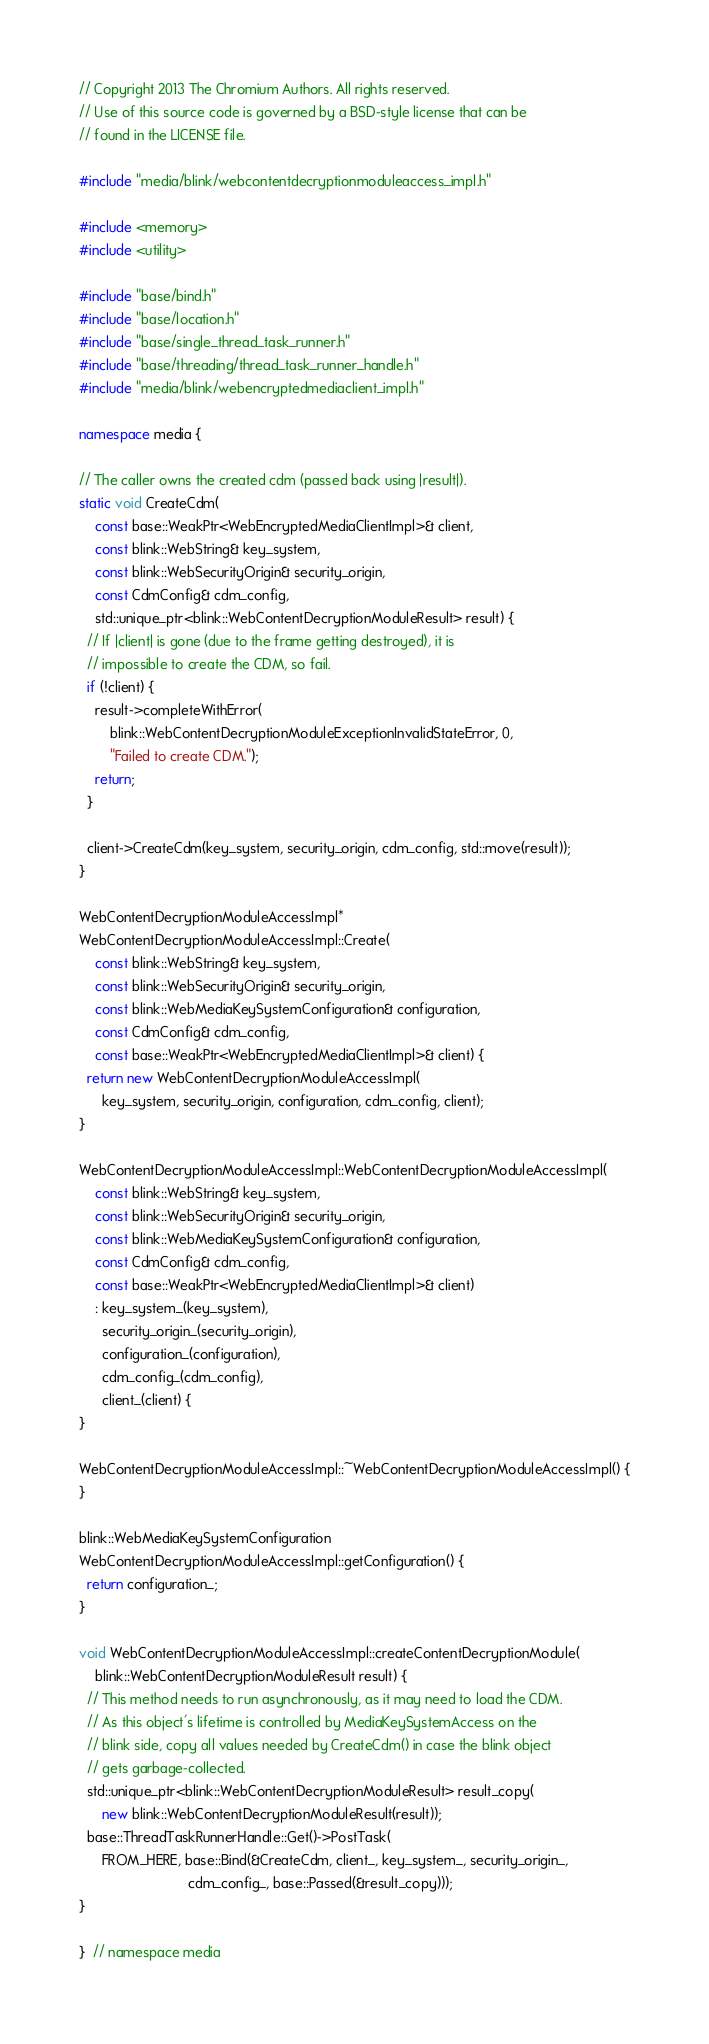Convert code to text. <code><loc_0><loc_0><loc_500><loc_500><_C++_>// Copyright 2013 The Chromium Authors. All rights reserved.
// Use of this source code is governed by a BSD-style license that can be
// found in the LICENSE file.

#include "media/blink/webcontentdecryptionmoduleaccess_impl.h"

#include <memory>
#include <utility>

#include "base/bind.h"
#include "base/location.h"
#include "base/single_thread_task_runner.h"
#include "base/threading/thread_task_runner_handle.h"
#include "media/blink/webencryptedmediaclient_impl.h"

namespace media {

// The caller owns the created cdm (passed back using |result|).
static void CreateCdm(
    const base::WeakPtr<WebEncryptedMediaClientImpl>& client,
    const blink::WebString& key_system,
    const blink::WebSecurityOrigin& security_origin,
    const CdmConfig& cdm_config,
    std::unique_ptr<blink::WebContentDecryptionModuleResult> result) {
  // If |client| is gone (due to the frame getting destroyed), it is
  // impossible to create the CDM, so fail.
  if (!client) {
    result->completeWithError(
        blink::WebContentDecryptionModuleExceptionInvalidStateError, 0,
        "Failed to create CDM.");
    return;
  }

  client->CreateCdm(key_system, security_origin, cdm_config, std::move(result));
}

WebContentDecryptionModuleAccessImpl*
WebContentDecryptionModuleAccessImpl::Create(
    const blink::WebString& key_system,
    const blink::WebSecurityOrigin& security_origin,
    const blink::WebMediaKeySystemConfiguration& configuration,
    const CdmConfig& cdm_config,
    const base::WeakPtr<WebEncryptedMediaClientImpl>& client) {
  return new WebContentDecryptionModuleAccessImpl(
      key_system, security_origin, configuration, cdm_config, client);
}

WebContentDecryptionModuleAccessImpl::WebContentDecryptionModuleAccessImpl(
    const blink::WebString& key_system,
    const blink::WebSecurityOrigin& security_origin,
    const blink::WebMediaKeySystemConfiguration& configuration,
    const CdmConfig& cdm_config,
    const base::WeakPtr<WebEncryptedMediaClientImpl>& client)
    : key_system_(key_system),
      security_origin_(security_origin),
      configuration_(configuration),
      cdm_config_(cdm_config),
      client_(client) {
}

WebContentDecryptionModuleAccessImpl::~WebContentDecryptionModuleAccessImpl() {
}

blink::WebMediaKeySystemConfiguration
WebContentDecryptionModuleAccessImpl::getConfiguration() {
  return configuration_;
}

void WebContentDecryptionModuleAccessImpl::createContentDecryptionModule(
    blink::WebContentDecryptionModuleResult result) {
  // This method needs to run asynchronously, as it may need to load the CDM.
  // As this object's lifetime is controlled by MediaKeySystemAccess on the
  // blink side, copy all values needed by CreateCdm() in case the blink object
  // gets garbage-collected.
  std::unique_ptr<blink::WebContentDecryptionModuleResult> result_copy(
      new blink::WebContentDecryptionModuleResult(result));
  base::ThreadTaskRunnerHandle::Get()->PostTask(
      FROM_HERE, base::Bind(&CreateCdm, client_, key_system_, security_origin_,
                            cdm_config_, base::Passed(&result_copy)));
}

}  // namespace media
</code> 